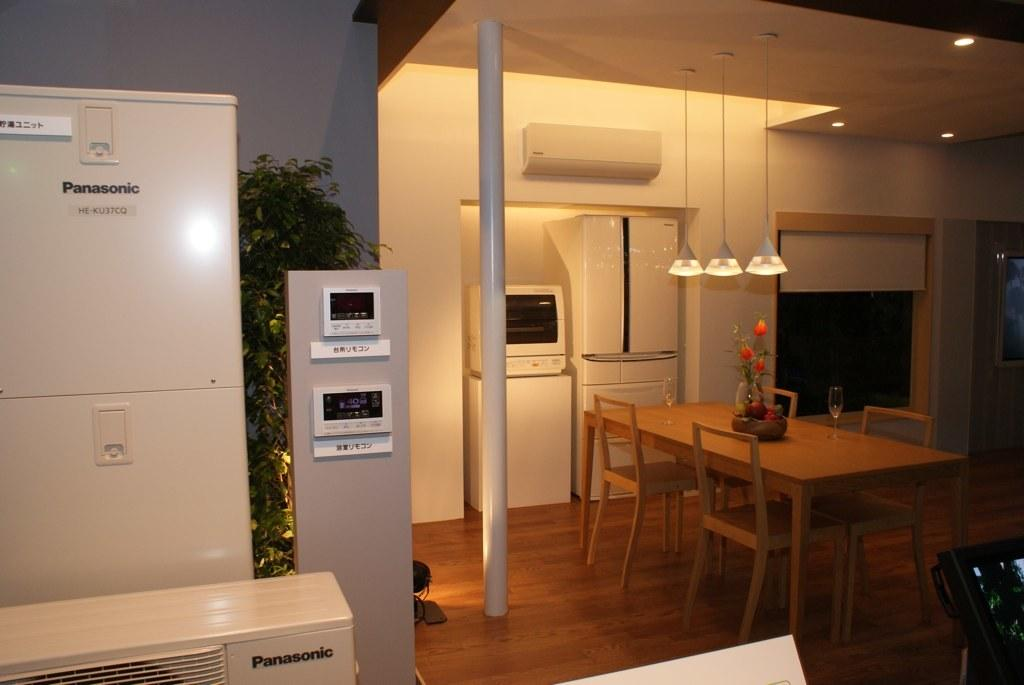What type of appliances can be seen in the image? There are refrigerators in the image. What type of furniture is present in the image? There are chairs and a table in the image. What type of glassware can be seen in the image? There are wine glasses in the image. What type of plant is present in the image? There is a house plant in the image. What type of lighting is present in the image? There are lights in the image. Are there any other objects present in the image besides the ones mentioned? Yes, there are other objects present in the image. What year is depicted in the image? The image does not depict a specific year; it is a still image of various objects. What type of border is present in the image? There is no border present in the image; it is a photograph or illustration of objects in a room. 